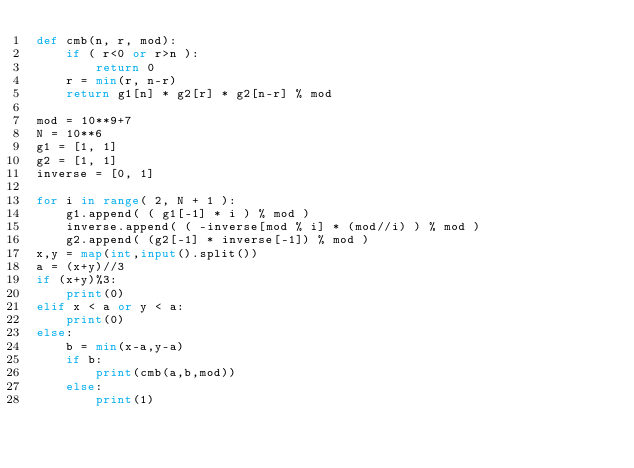Convert code to text. <code><loc_0><loc_0><loc_500><loc_500><_Python_>def cmb(n, r, mod):
    if ( r<0 or r>n ):
        return 0
    r = min(r, n-r)
    return g1[n] * g2[r] * g2[n-r] % mod

mod = 10**9+7
N = 10**6
g1 = [1, 1]
g2 = [1, 1]
inverse = [0, 1]

for i in range( 2, N + 1 ):
    g1.append( ( g1[-1] * i ) % mod )
    inverse.append( ( -inverse[mod % i] * (mod//i) ) % mod )
    g2.append( (g2[-1] * inverse[-1]) % mod )
x,y = map(int,input().split())
a = (x+y)//3
if (x+y)%3:
    print(0)
elif x < a or y < a:
    print(0)
else:
    b = min(x-a,y-a)
    if b:
        print(cmb(a,b,mod))
    else:
        print(1)
</code> 